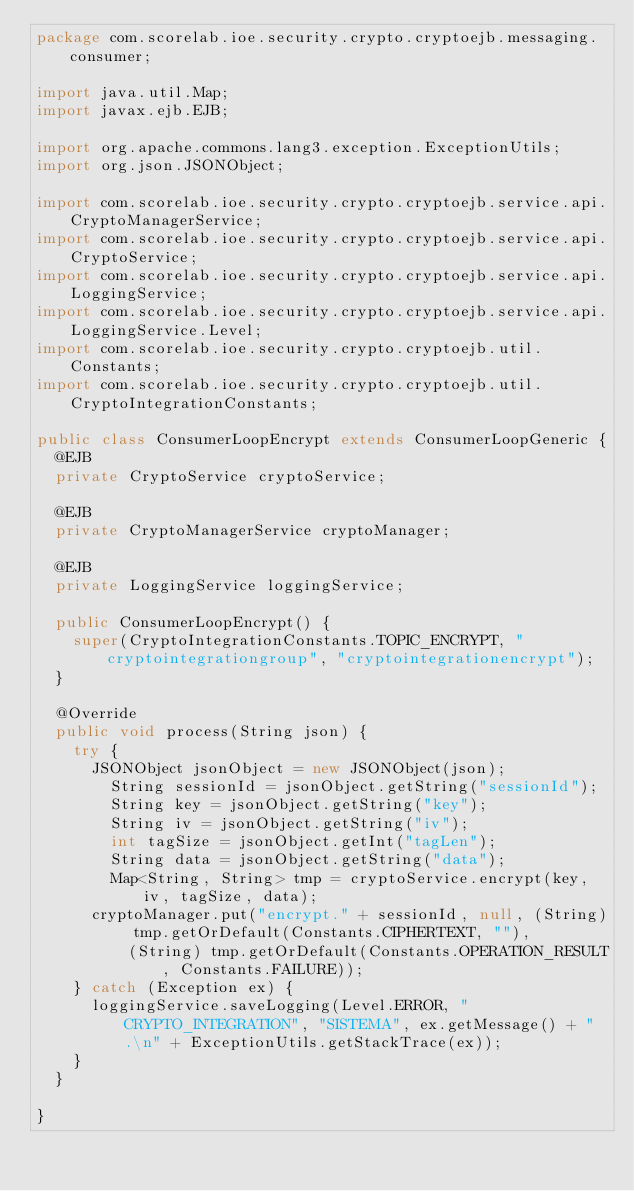<code> <loc_0><loc_0><loc_500><loc_500><_Java_>package com.scorelab.ioe.security.crypto.cryptoejb.messaging.consumer;

import java.util.Map;
import javax.ejb.EJB;

import org.apache.commons.lang3.exception.ExceptionUtils;
import org.json.JSONObject;

import com.scorelab.ioe.security.crypto.cryptoejb.service.api.CryptoManagerService;
import com.scorelab.ioe.security.crypto.cryptoejb.service.api.CryptoService;
import com.scorelab.ioe.security.crypto.cryptoejb.service.api.LoggingService;
import com.scorelab.ioe.security.crypto.cryptoejb.service.api.LoggingService.Level;
import com.scorelab.ioe.security.crypto.cryptoejb.util.Constants;
import com.scorelab.ioe.security.crypto.cryptoejb.util.CryptoIntegrationConstants;

public class ConsumerLoopEncrypt extends ConsumerLoopGeneric {
	@EJB
	private CryptoService cryptoService;  

	@EJB
	private CryptoManagerService cryptoManager;
	
	@EJB
	private LoggingService loggingService;

	public ConsumerLoopEncrypt() {
		super(CryptoIntegrationConstants.TOPIC_ENCRYPT, "cryptointegrationgroup", "cryptointegrationencrypt");
	}

	@Override
	public void process(String json) {
		try {
			JSONObject jsonObject = new JSONObject(json);
	    	String sessionId = jsonObject.getString("sessionId");
	    	String key = jsonObject.getString("key");
	    	String iv = jsonObject.getString("iv");
	    	int tagSize = jsonObject.getInt("tagLen");
	    	String data = jsonObject.getString("data");
	    	Map<String, String> tmp = cryptoService.encrypt(key, iv, tagSize, data);
			cryptoManager.put("encrypt." + sessionId, null, (String) tmp.getOrDefault(Constants.CIPHERTEXT, ""),
					(String) tmp.getOrDefault(Constants.OPERATION_RESULT, Constants.FAILURE));
		} catch (Exception ex) {
			loggingService.saveLogging(Level.ERROR, "CRYPTO_INTEGRATION", "SISTEMA", ex.getMessage() + ".\n" + ExceptionUtils.getStackTrace(ex));
		}
	}
	
}</code> 